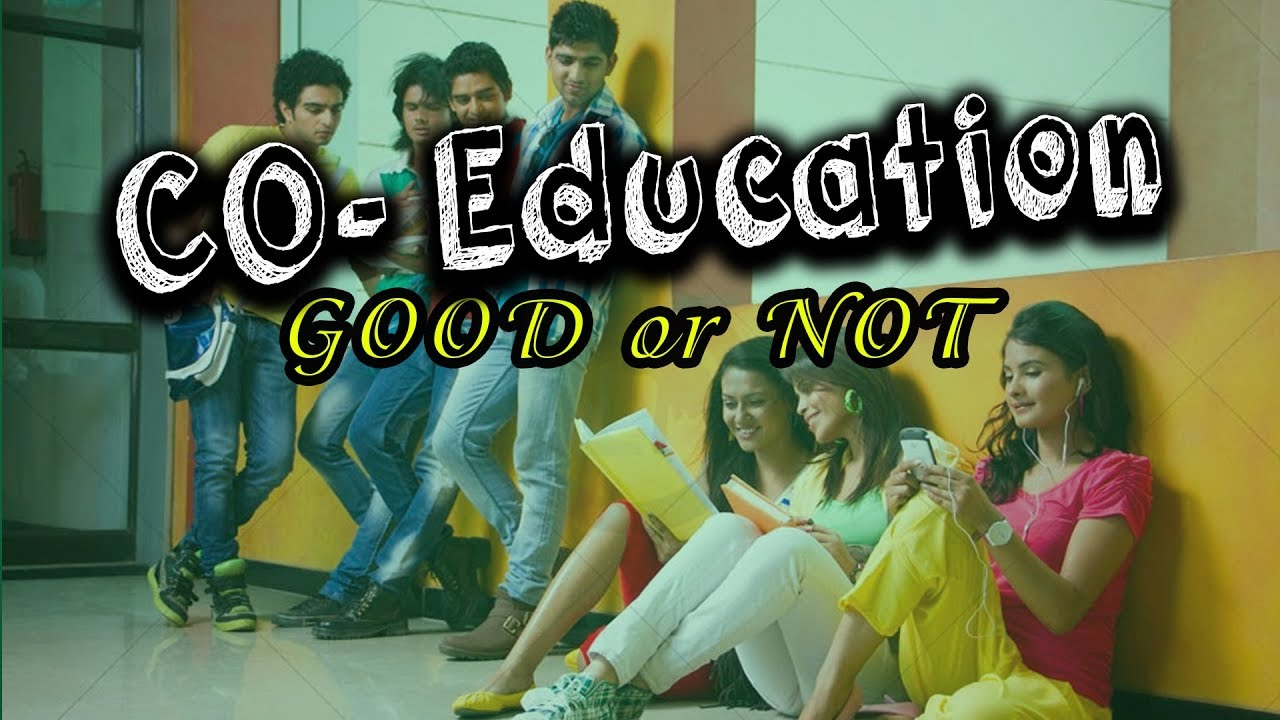Considering the posture and facial expressions of the people in the image, what can be inferred about their level of engagement or interest in the activity they are involved in? Upon examining the image, we observe a group of young adults in a setting that appears to be a casual academic environment. Each individual's posture and expression suggest varying degrees of involvement in their respective activities. The young men resting against the wall seem to be engrossed in a communal task, likely an educational discussion, which is signaled by one individual holding academic materials and the intent gaze of his peers. In contrast, the young woman wearing headphones appears to be disengaged from the group's collaborative effort, instead choosing to indulge in private entertainment as seen by her relaxed posture and focus on her phone. Finally, the woman sitting with crossed legs is concentrating solely on the content of her notebook, indicative of personal engagement in her study. The overall scene depicts a snapshot of modern educational interactions, blending focused individual study with group collaboration. 